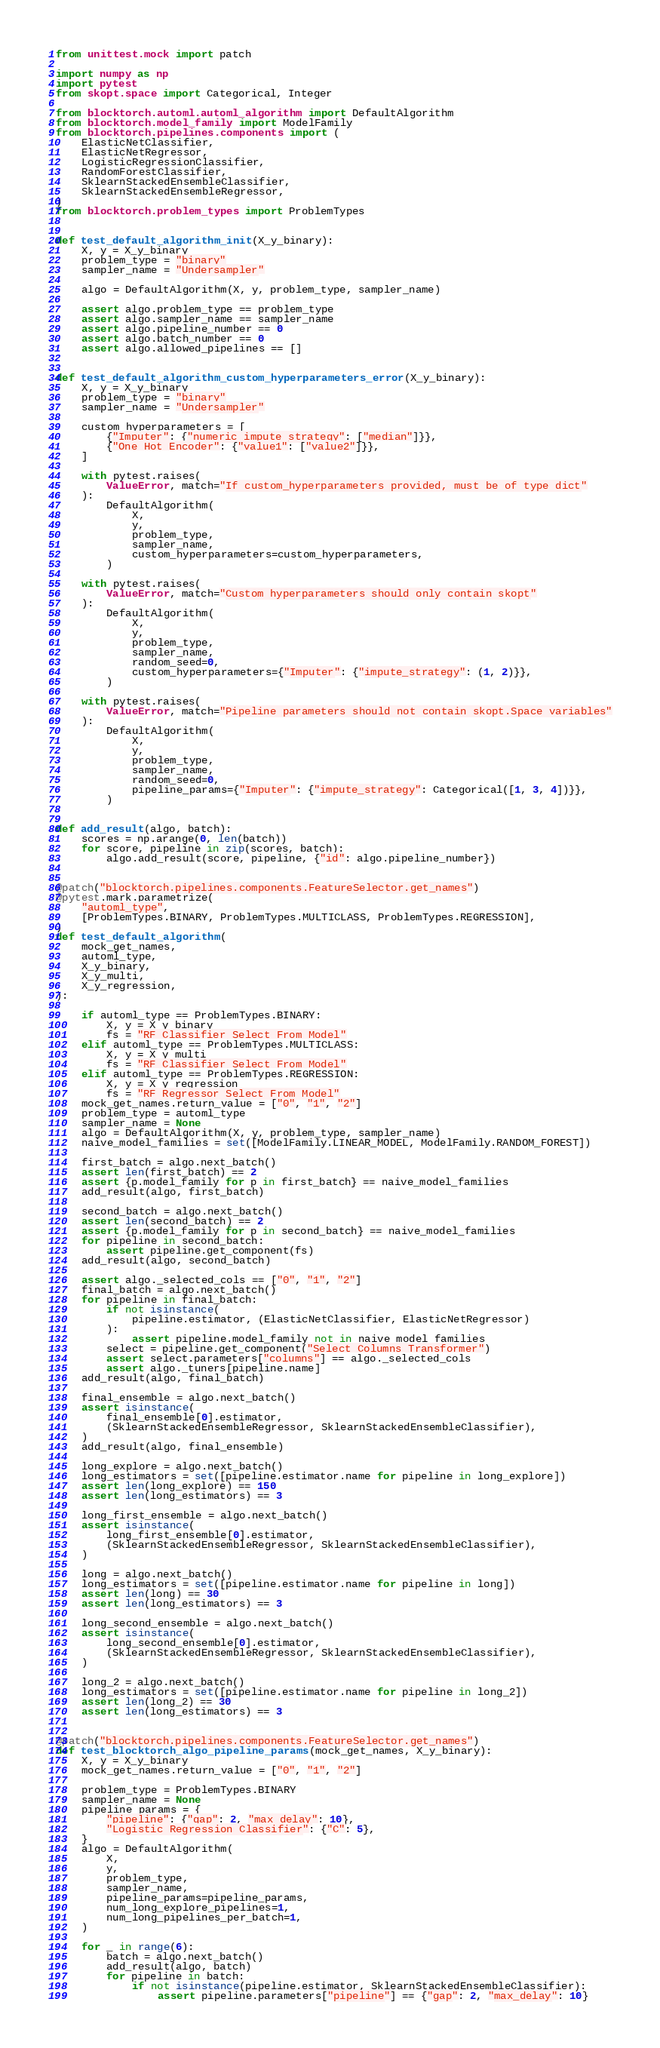<code> <loc_0><loc_0><loc_500><loc_500><_Python_>from unittest.mock import patch

import numpy as np
import pytest
from skopt.space import Categorical, Integer

from blocktorch.automl.automl_algorithm import DefaultAlgorithm
from blocktorch.model_family import ModelFamily
from blocktorch.pipelines.components import (
    ElasticNetClassifier,
    ElasticNetRegressor,
    LogisticRegressionClassifier,
    RandomForestClassifier,
    SklearnStackedEnsembleClassifier,
    SklearnStackedEnsembleRegressor,
)
from blocktorch.problem_types import ProblemTypes


def test_default_algorithm_init(X_y_binary):
    X, y = X_y_binary
    problem_type = "binary"
    sampler_name = "Undersampler"

    algo = DefaultAlgorithm(X, y, problem_type, sampler_name)

    assert algo.problem_type == problem_type
    assert algo.sampler_name == sampler_name
    assert algo.pipeline_number == 0
    assert algo.batch_number == 0
    assert algo.allowed_pipelines == []


def test_default_algorithm_custom_hyperparameters_error(X_y_binary):
    X, y = X_y_binary
    problem_type = "binary"
    sampler_name = "Undersampler"

    custom_hyperparameters = [
        {"Imputer": {"numeric_impute_strategy": ["median"]}},
        {"One Hot Encoder": {"value1": ["value2"]}},
    ]

    with pytest.raises(
        ValueError, match="If custom_hyperparameters provided, must be of type dict"
    ):
        DefaultAlgorithm(
            X,
            y,
            problem_type,
            sampler_name,
            custom_hyperparameters=custom_hyperparameters,
        )

    with pytest.raises(
        ValueError, match="Custom hyperparameters should only contain skopt"
    ):
        DefaultAlgorithm(
            X,
            y,
            problem_type,
            sampler_name,
            random_seed=0,
            custom_hyperparameters={"Imputer": {"impute_strategy": (1, 2)}},
        )

    with pytest.raises(
        ValueError, match="Pipeline parameters should not contain skopt.Space variables"
    ):
        DefaultAlgorithm(
            X,
            y,
            problem_type,
            sampler_name,
            random_seed=0,
            pipeline_params={"Imputer": {"impute_strategy": Categorical([1, 3, 4])}},
        )


def add_result(algo, batch):
    scores = np.arange(0, len(batch))
    for score, pipeline in zip(scores, batch):
        algo.add_result(score, pipeline, {"id": algo.pipeline_number})


@patch("blocktorch.pipelines.components.FeatureSelector.get_names")
@pytest.mark.parametrize(
    "automl_type",
    [ProblemTypes.BINARY, ProblemTypes.MULTICLASS, ProblemTypes.REGRESSION],
)
def test_default_algorithm(
    mock_get_names,
    automl_type,
    X_y_binary,
    X_y_multi,
    X_y_regression,
):

    if automl_type == ProblemTypes.BINARY:
        X, y = X_y_binary
        fs = "RF Classifier Select From Model"
    elif automl_type == ProblemTypes.MULTICLASS:
        X, y = X_y_multi
        fs = "RF Classifier Select From Model"
    elif automl_type == ProblemTypes.REGRESSION:
        X, y = X_y_regression
        fs = "RF Regressor Select From Model"
    mock_get_names.return_value = ["0", "1", "2"]
    problem_type = automl_type
    sampler_name = None
    algo = DefaultAlgorithm(X, y, problem_type, sampler_name)
    naive_model_families = set([ModelFamily.LINEAR_MODEL, ModelFamily.RANDOM_FOREST])

    first_batch = algo.next_batch()
    assert len(first_batch) == 2
    assert {p.model_family for p in first_batch} == naive_model_families
    add_result(algo, first_batch)

    second_batch = algo.next_batch()
    assert len(second_batch) == 2
    assert {p.model_family for p in second_batch} == naive_model_families
    for pipeline in second_batch:
        assert pipeline.get_component(fs)
    add_result(algo, second_batch)

    assert algo._selected_cols == ["0", "1", "2"]
    final_batch = algo.next_batch()
    for pipeline in final_batch:
        if not isinstance(
            pipeline.estimator, (ElasticNetClassifier, ElasticNetRegressor)
        ):
            assert pipeline.model_family not in naive_model_families
        select = pipeline.get_component("Select Columns Transformer")
        assert select.parameters["columns"] == algo._selected_cols
        assert algo._tuners[pipeline.name]
    add_result(algo, final_batch)

    final_ensemble = algo.next_batch()
    assert isinstance(
        final_ensemble[0].estimator,
        (SklearnStackedEnsembleRegressor, SklearnStackedEnsembleClassifier),
    )
    add_result(algo, final_ensemble)

    long_explore = algo.next_batch()
    long_estimators = set([pipeline.estimator.name for pipeline in long_explore])
    assert len(long_explore) == 150
    assert len(long_estimators) == 3

    long_first_ensemble = algo.next_batch()
    assert isinstance(
        long_first_ensemble[0].estimator,
        (SklearnStackedEnsembleRegressor, SklearnStackedEnsembleClassifier),
    )

    long = algo.next_batch()
    long_estimators = set([pipeline.estimator.name for pipeline in long])
    assert len(long) == 30
    assert len(long_estimators) == 3

    long_second_ensemble = algo.next_batch()
    assert isinstance(
        long_second_ensemble[0].estimator,
        (SklearnStackedEnsembleRegressor, SklearnStackedEnsembleClassifier),
    )

    long_2 = algo.next_batch()
    long_estimators = set([pipeline.estimator.name for pipeline in long_2])
    assert len(long_2) == 30
    assert len(long_estimators) == 3


@patch("blocktorch.pipelines.components.FeatureSelector.get_names")
def test_blocktorch_algo_pipeline_params(mock_get_names, X_y_binary):
    X, y = X_y_binary
    mock_get_names.return_value = ["0", "1", "2"]

    problem_type = ProblemTypes.BINARY
    sampler_name = None
    pipeline_params = {
        "pipeline": {"gap": 2, "max_delay": 10},
        "Logistic Regression Classifier": {"C": 5},
    }
    algo = DefaultAlgorithm(
        X,
        y,
        problem_type,
        sampler_name,
        pipeline_params=pipeline_params,
        num_long_explore_pipelines=1,
        num_long_pipelines_per_batch=1,
    )

    for _ in range(6):
        batch = algo.next_batch()
        add_result(algo, batch)
        for pipeline in batch:
            if not isinstance(pipeline.estimator, SklearnStackedEnsembleClassifier):
                assert pipeline.parameters["pipeline"] == {"gap": 2, "max_delay": 10}</code> 